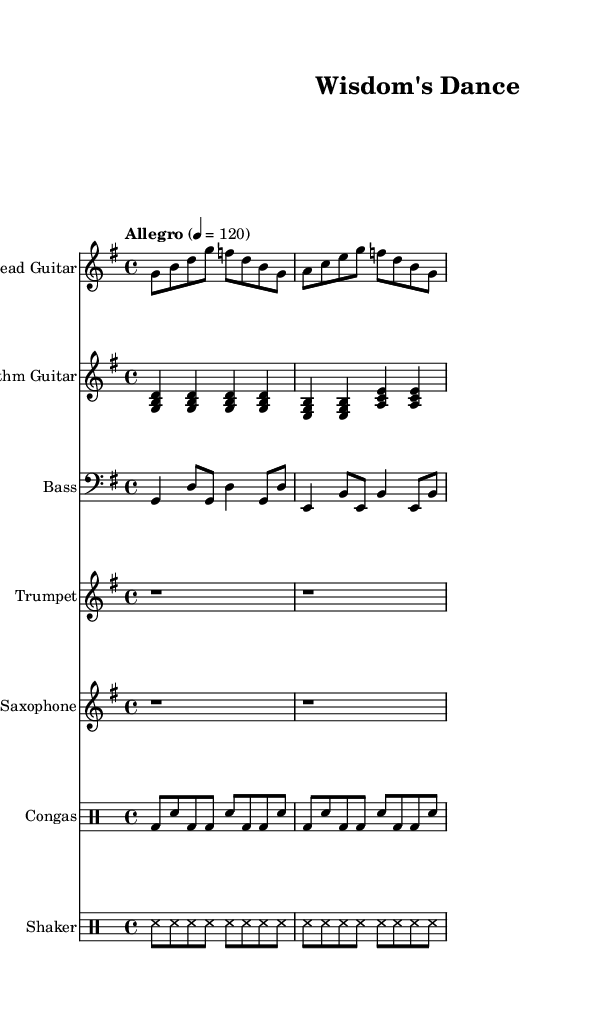What is the key signature of this music? The music is in G major as indicated by the key signature, which has one sharp, F#.
Answer: G major What is the time signature of the piece? The time signature is 4/4, which means there are four beats in each measure and the quarter note gets one beat.
Answer: 4/4 What is the tempo marking given in the music? The tempo marking is "Allegro," indicating a lively tempo of 120 beats per minute, as notated.
Answer: Allegro How many measures does the lead guitar part consist of in this piece? The lead guitar section has four measures as indicated through the sequential bars in the notation.
Answer: 4 What instrument plays the rhythm guitar part? The rhythm guitar part is assigned to the instrument labeled as "Rhythm Guitar" in the score.
Answer: Rhythm Guitar Which component of the ensemble does not have melody notes written? Both the congas and shaker parts consist solely of percussion and rhythmic notes without melody, indicated by the use of drummode.
Answer: Congas and Shaker How many different instruments are featured in the score? There are six different instruments featured in the score: Lead Guitar, Rhythm Guitar, Bass, Trumpet, Saxophone, and Congas.
Answer: 6 